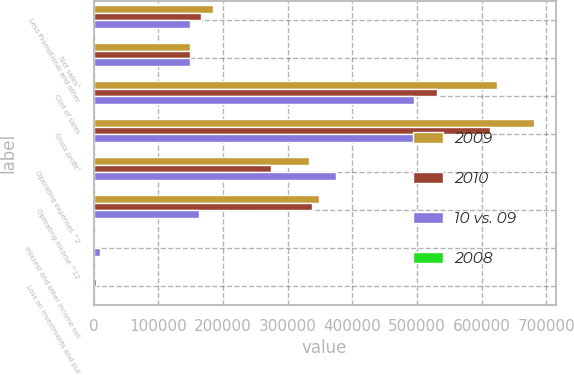<chart> <loc_0><loc_0><loc_500><loc_500><stacked_bar_chart><ecel><fcel>Less Promotional and other<fcel>Net sales¹<fcel>Cost of sales<fcel>Gross profit¹<fcel>Operating expenses ^2<fcel>Operating income ^12<fcel>Interest and other income net<fcel>Loss on investments and put<nl><fcel>2009<fcel>184574<fcel>149096<fcel>623702<fcel>680240<fcel>332426<fcel>347814<fcel>2246<fcel>758<nl><fcel>2010<fcel>166036<fcel>149096<fcel>530983<fcel>612316<fcel>275007<fcel>337309<fcel>2273<fcel>3887<nl><fcel>10 vs. 09<fcel>149096<fcel>149096<fcel>494986<fcel>538794<fcel>375203<fcel>163591<fcel>10413<fcel>527<nl><fcel>2008<fcel>11.2<fcel>14.1<fcel>17.5<fcel>11.1<fcel>20.9<fcel>3.1<fcel>1.2<fcel>80.5<nl></chart> 